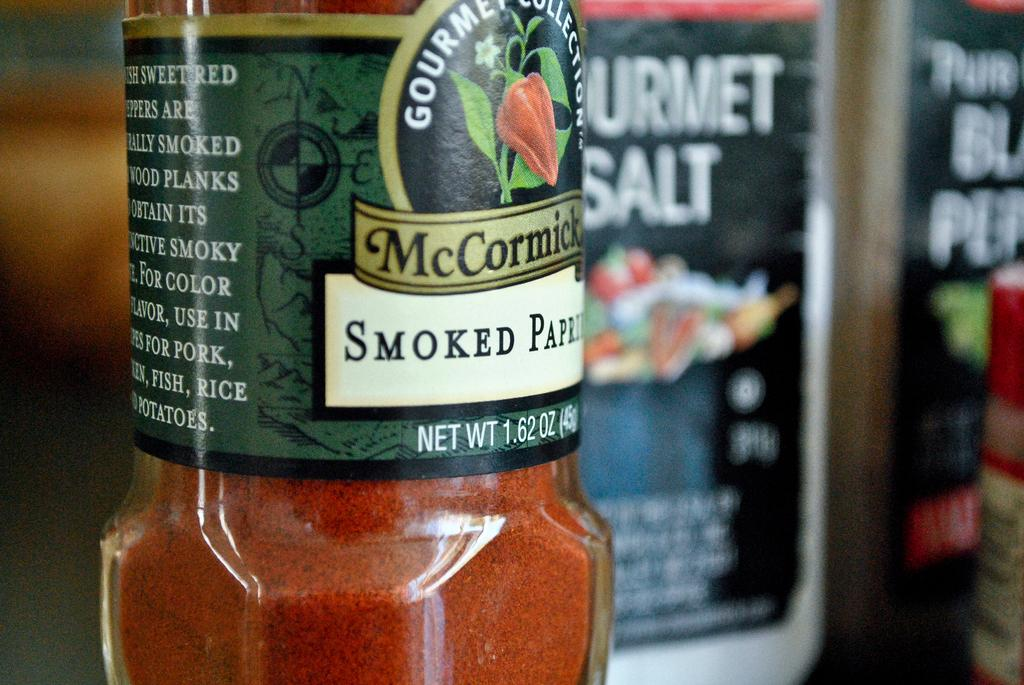<image>
Describe the image concisely. The spice jar contains McCormick brand smoked paprika. 